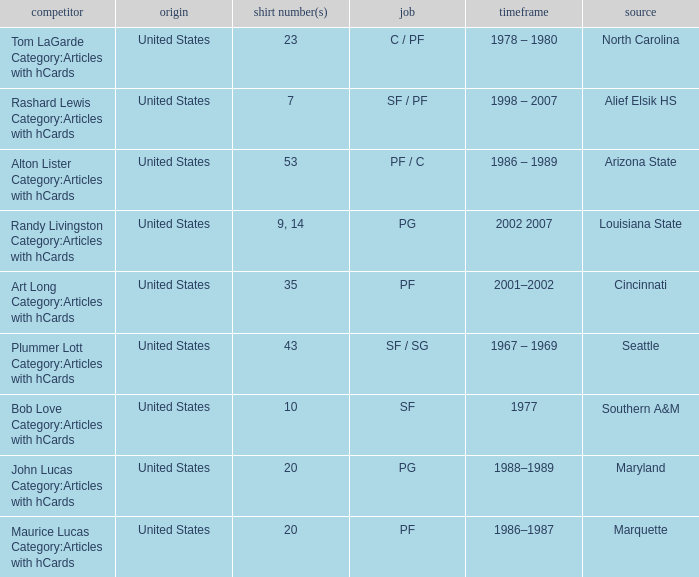Could you parse the entire table? {'header': ['competitor', 'origin', 'shirt number(s)', 'job', 'timeframe', 'source'], 'rows': [['Tom LaGarde Category:Articles with hCards', 'United States', '23', 'C / PF', '1978 – 1980', 'North Carolina'], ['Rashard Lewis Category:Articles with hCards', 'United States', '7', 'SF / PF', '1998 – 2007', 'Alief Elsik HS'], ['Alton Lister Category:Articles with hCards', 'United States', '53', 'PF / C', '1986 – 1989', 'Arizona State'], ['Randy Livingston Category:Articles with hCards', 'United States', '9, 14', 'PG', '2002 2007', 'Louisiana State'], ['Art Long Category:Articles with hCards', 'United States', '35', 'PF', '2001–2002', 'Cincinnati'], ['Plummer Lott Category:Articles with hCards', 'United States', '43', 'SF / SG', '1967 – 1969', 'Seattle'], ['Bob Love Category:Articles with hCards', 'United States', '10', 'SF', '1977', 'Southern A&M'], ['John Lucas Category:Articles with hCards', 'United States', '20', 'PG', '1988–1989', 'Maryland'], ['Maurice Lucas Category:Articles with hCards', 'United States', '20', 'PF', '1986–1987', 'Marquette']]} Tom Lagarde Category:Articles with hCards used what Jersey Number(s)? 23.0. 